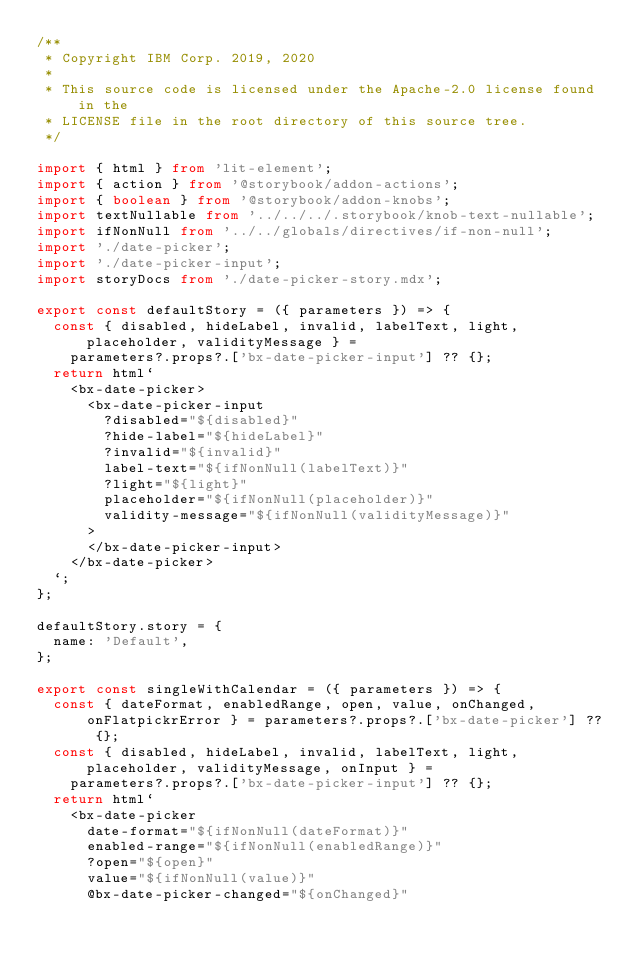<code> <loc_0><loc_0><loc_500><loc_500><_TypeScript_>/**
 * Copyright IBM Corp. 2019, 2020
 *
 * This source code is licensed under the Apache-2.0 license found in the
 * LICENSE file in the root directory of this source tree.
 */

import { html } from 'lit-element';
import { action } from '@storybook/addon-actions';
import { boolean } from '@storybook/addon-knobs';
import textNullable from '../../../.storybook/knob-text-nullable';
import ifNonNull from '../../globals/directives/if-non-null';
import './date-picker';
import './date-picker-input';
import storyDocs from './date-picker-story.mdx';

export const defaultStory = ({ parameters }) => {
  const { disabled, hideLabel, invalid, labelText, light, placeholder, validityMessage } =
    parameters?.props?.['bx-date-picker-input'] ?? {};
  return html`
    <bx-date-picker>
      <bx-date-picker-input
        ?disabled="${disabled}"
        ?hide-label="${hideLabel}"
        ?invalid="${invalid}"
        label-text="${ifNonNull(labelText)}"
        ?light="${light}"
        placeholder="${ifNonNull(placeholder)}"
        validity-message="${ifNonNull(validityMessage)}"
      >
      </bx-date-picker-input>
    </bx-date-picker>
  `;
};

defaultStory.story = {
  name: 'Default',
};

export const singleWithCalendar = ({ parameters }) => {
  const { dateFormat, enabledRange, open, value, onChanged, onFlatpickrError } = parameters?.props?.['bx-date-picker'] ?? {};
  const { disabled, hideLabel, invalid, labelText, light, placeholder, validityMessage, onInput } =
    parameters?.props?.['bx-date-picker-input'] ?? {};
  return html`
    <bx-date-picker
      date-format="${ifNonNull(dateFormat)}"
      enabled-range="${ifNonNull(enabledRange)}"
      ?open="${open}"
      value="${ifNonNull(value)}"
      @bx-date-picker-changed="${onChanged}"</code> 